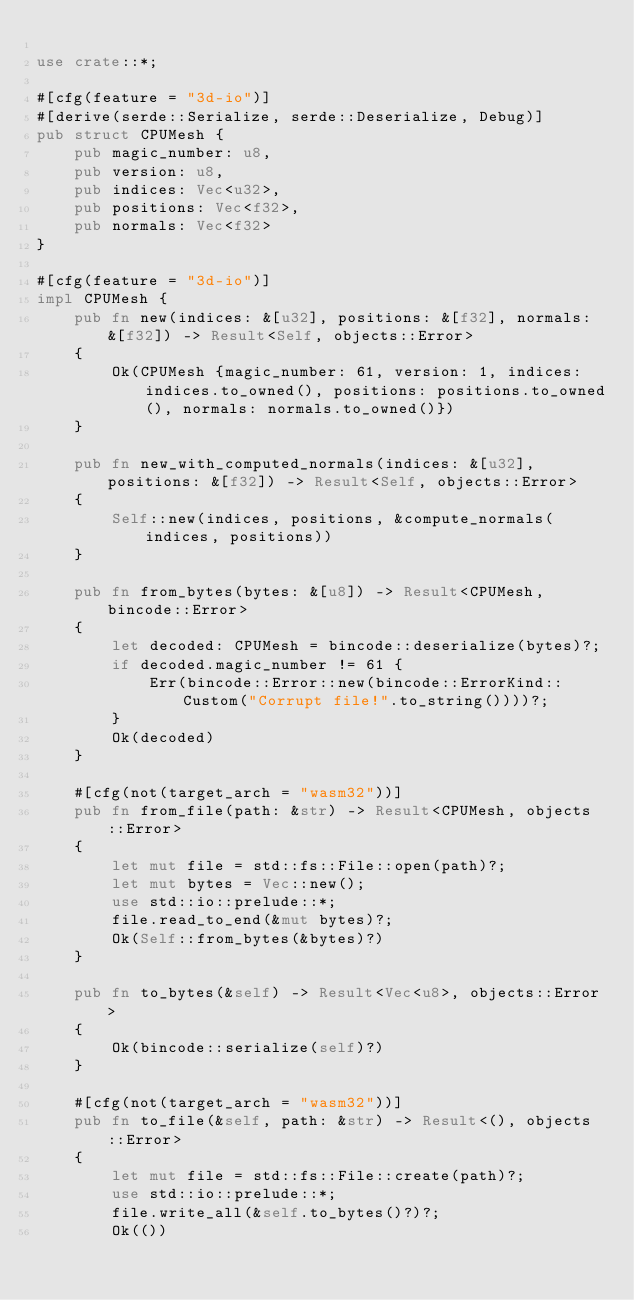Convert code to text. <code><loc_0><loc_0><loc_500><loc_500><_Rust_>
use crate::*;

#[cfg(feature = "3d-io")]
#[derive(serde::Serialize, serde::Deserialize, Debug)]
pub struct CPUMesh {
    pub magic_number: u8,
    pub version: u8,
    pub indices: Vec<u32>,
    pub positions: Vec<f32>,
    pub normals: Vec<f32>
}

#[cfg(feature = "3d-io")]
impl CPUMesh {
    pub fn new(indices: &[u32], positions: &[f32], normals: &[f32]) -> Result<Self, objects::Error>
    {
        Ok(CPUMesh {magic_number: 61, version: 1, indices: indices.to_owned(), positions: positions.to_owned(), normals: normals.to_owned()})
    }

    pub fn new_with_computed_normals(indices: &[u32], positions: &[f32]) -> Result<Self, objects::Error>
    {
        Self::new(indices, positions, &compute_normals(indices, positions))
    }

    pub fn from_bytes(bytes: &[u8]) -> Result<CPUMesh, bincode::Error>
    {
        let decoded: CPUMesh = bincode::deserialize(bytes)?;
        if decoded.magic_number != 61 {
            Err(bincode::Error::new(bincode::ErrorKind::Custom("Corrupt file!".to_string())))?;
        }
        Ok(decoded)
    }

    #[cfg(not(target_arch = "wasm32"))]
    pub fn from_file(path: &str) -> Result<CPUMesh, objects::Error>
    {
        let mut file = std::fs::File::open(path)?;
        let mut bytes = Vec::new();
        use std::io::prelude::*;
        file.read_to_end(&mut bytes)?;
        Ok(Self::from_bytes(&bytes)?)
    }

    pub fn to_bytes(&self) -> Result<Vec<u8>, objects::Error>
    {
        Ok(bincode::serialize(self)?)
    }

    #[cfg(not(target_arch = "wasm32"))]
    pub fn to_file(&self, path: &str) -> Result<(), objects::Error>
    {
        let mut file = std::fs::File::create(path)?;
        use std::io::prelude::*;
        file.write_all(&self.to_bytes()?)?;
        Ok(())</code> 